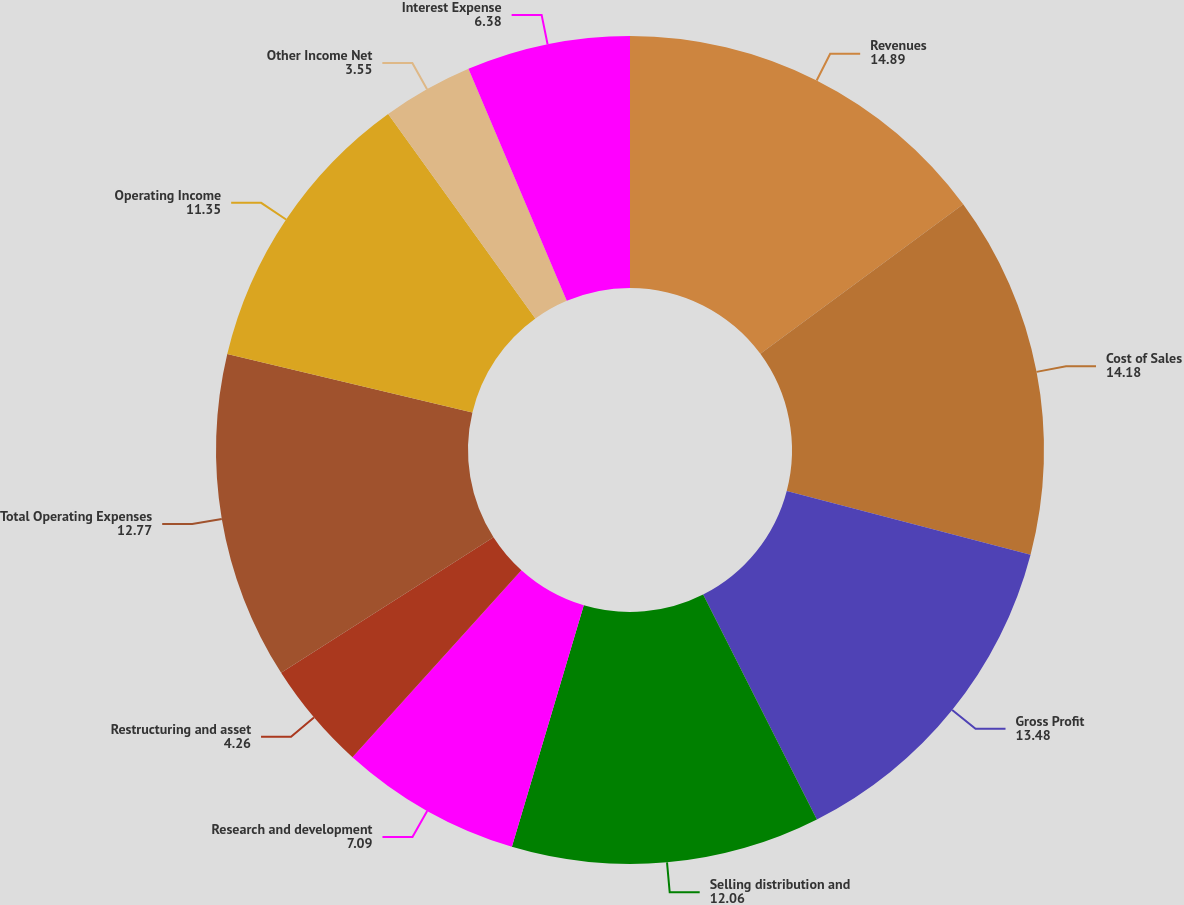<chart> <loc_0><loc_0><loc_500><loc_500><pie_chart><fcel>Revenues<fcel>Cost of Sales<fcel>Gross Profit<fcel>Selling distribution and<fcel>Research and development<fcel>Restructuring and asset<fcel>Total Operating Expenses<fcel>Operating Income<fcel>Other Income Net<fcel>Interest Expense<nl><fcel>14.89%<fcel>14.18%<fcel>13.48%<fcel>12.06%<fcel>7.09%<fcel>4.26%<fcel>12.77%<fcel>11.35%<fcel>3.55%<fcel>6.38%<nl></chart> 